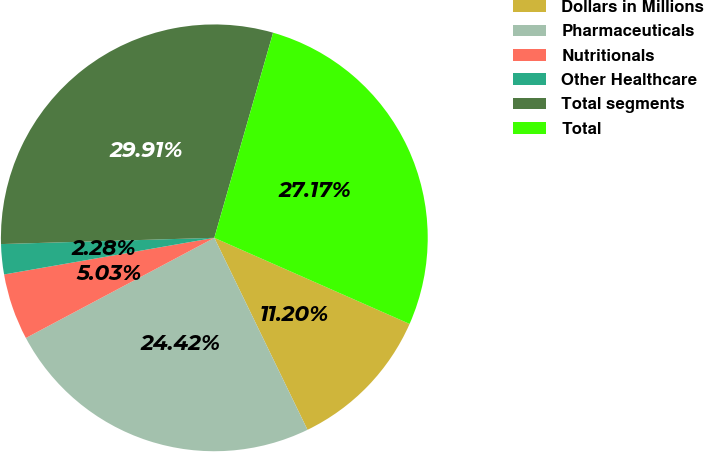Convert chart. <chart><loc_0><loc_0><loc_500><loc_500><pie_chart><fcel>Dollars in Millions<fcel>Pharmaceuticals<fcel>Nutritionals<fcel>Other Healthcare<fcel>Total segments<fcel>Total<nl><fcel>11.2%<fcel>24.42%<fcel>5.03%<fcel>2.28%<fcel>29.91%<fcel>27.17%<nl></chart> 